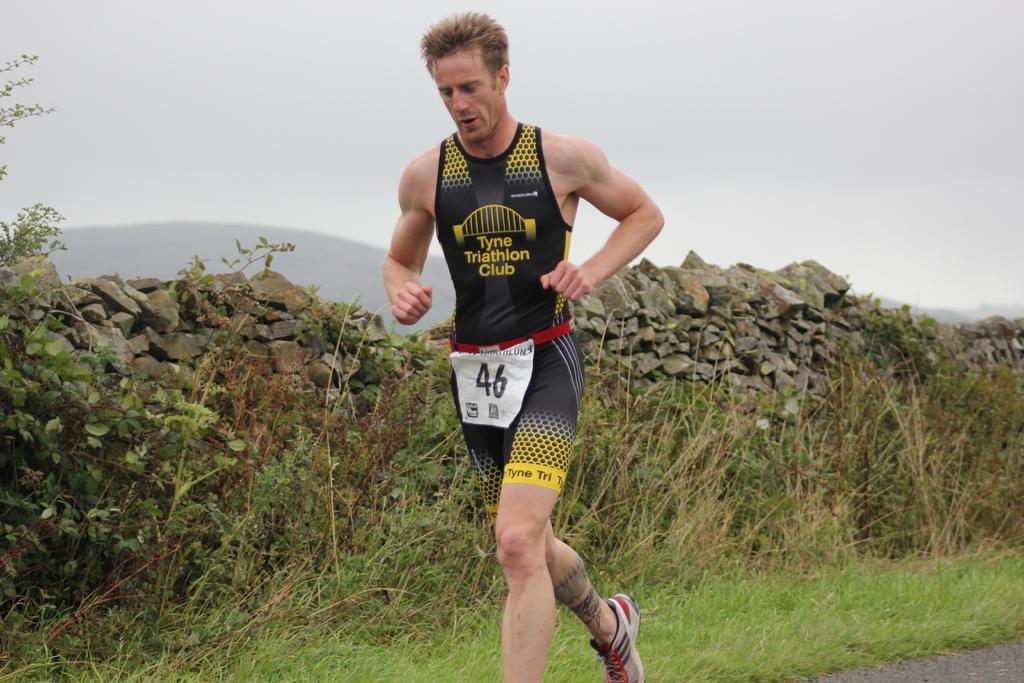Where does this jersey say the man is from?
Provide a succinct answer. Tyne triathlon club. What is the runner's number?
Your answer should be very brief. 46. 